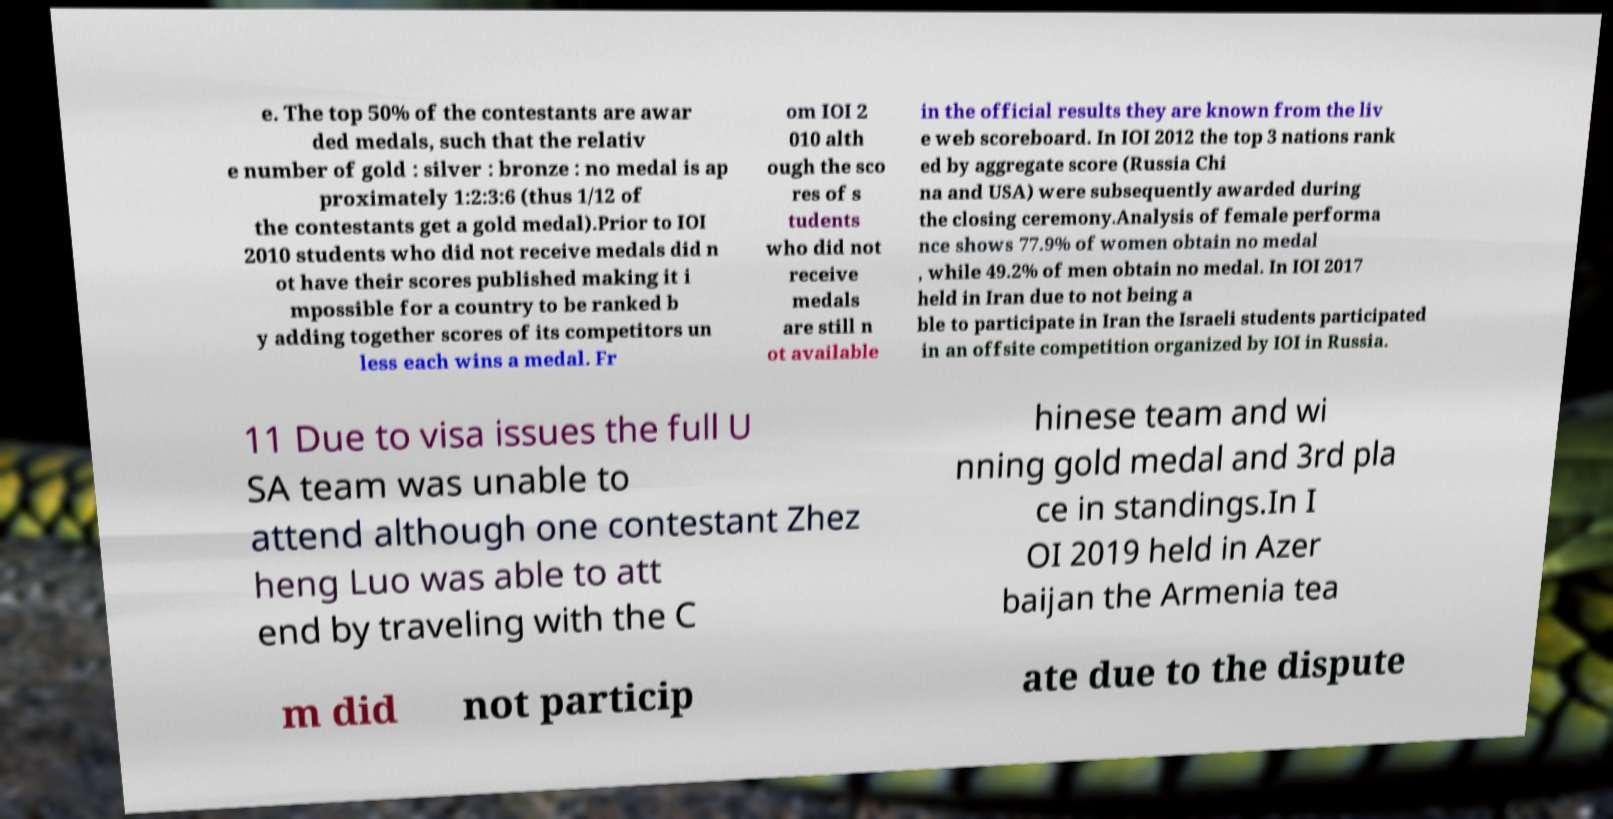There's text embedded in this image that I need extracted. Can you transcribe it verbatim? e. The top 50% of the contestants are awar ded medals, such that the relativ e number of gold : silver : bronze : no medal is ap proximately 1:2:3:6 (thus 1/12 of the contestants get a gold medal).Prior to IOI 2010 students who did not receive medals did n ot have their scores published making it i mpossible for a country to be ranked b y adding together scores of its competitors un less each wins a medal. Fr om IOI 2 010 alth ough the sco res of s tudents who did not receive medals are still n ot available in the official results they are known from the liv e web scoreboard. In IOI 2012 the top 3 nations rank ed by aggregate score (Russia Chi na and USA) were subsequently awarded during the closing ceremony.Analysis of female performa nce shows 77.9% of women obtain no medal , while 49.2% of men obtain no medal. In IOI 2017 held in Iran due to not being a ble to participate in Iran the Israeli students participated in an offsite competition organized by IOI in Russia. 11 Due to visa issues the full U SA team was unable to attend although one contestant Zhez heng Luo was able to att end by traveling with the C hinese team and wi nning gold medal and 3rd pla ce in standings.In I OI 2019 held in Azer baijan the Armenia tea m did not particip ate due to the dispute 